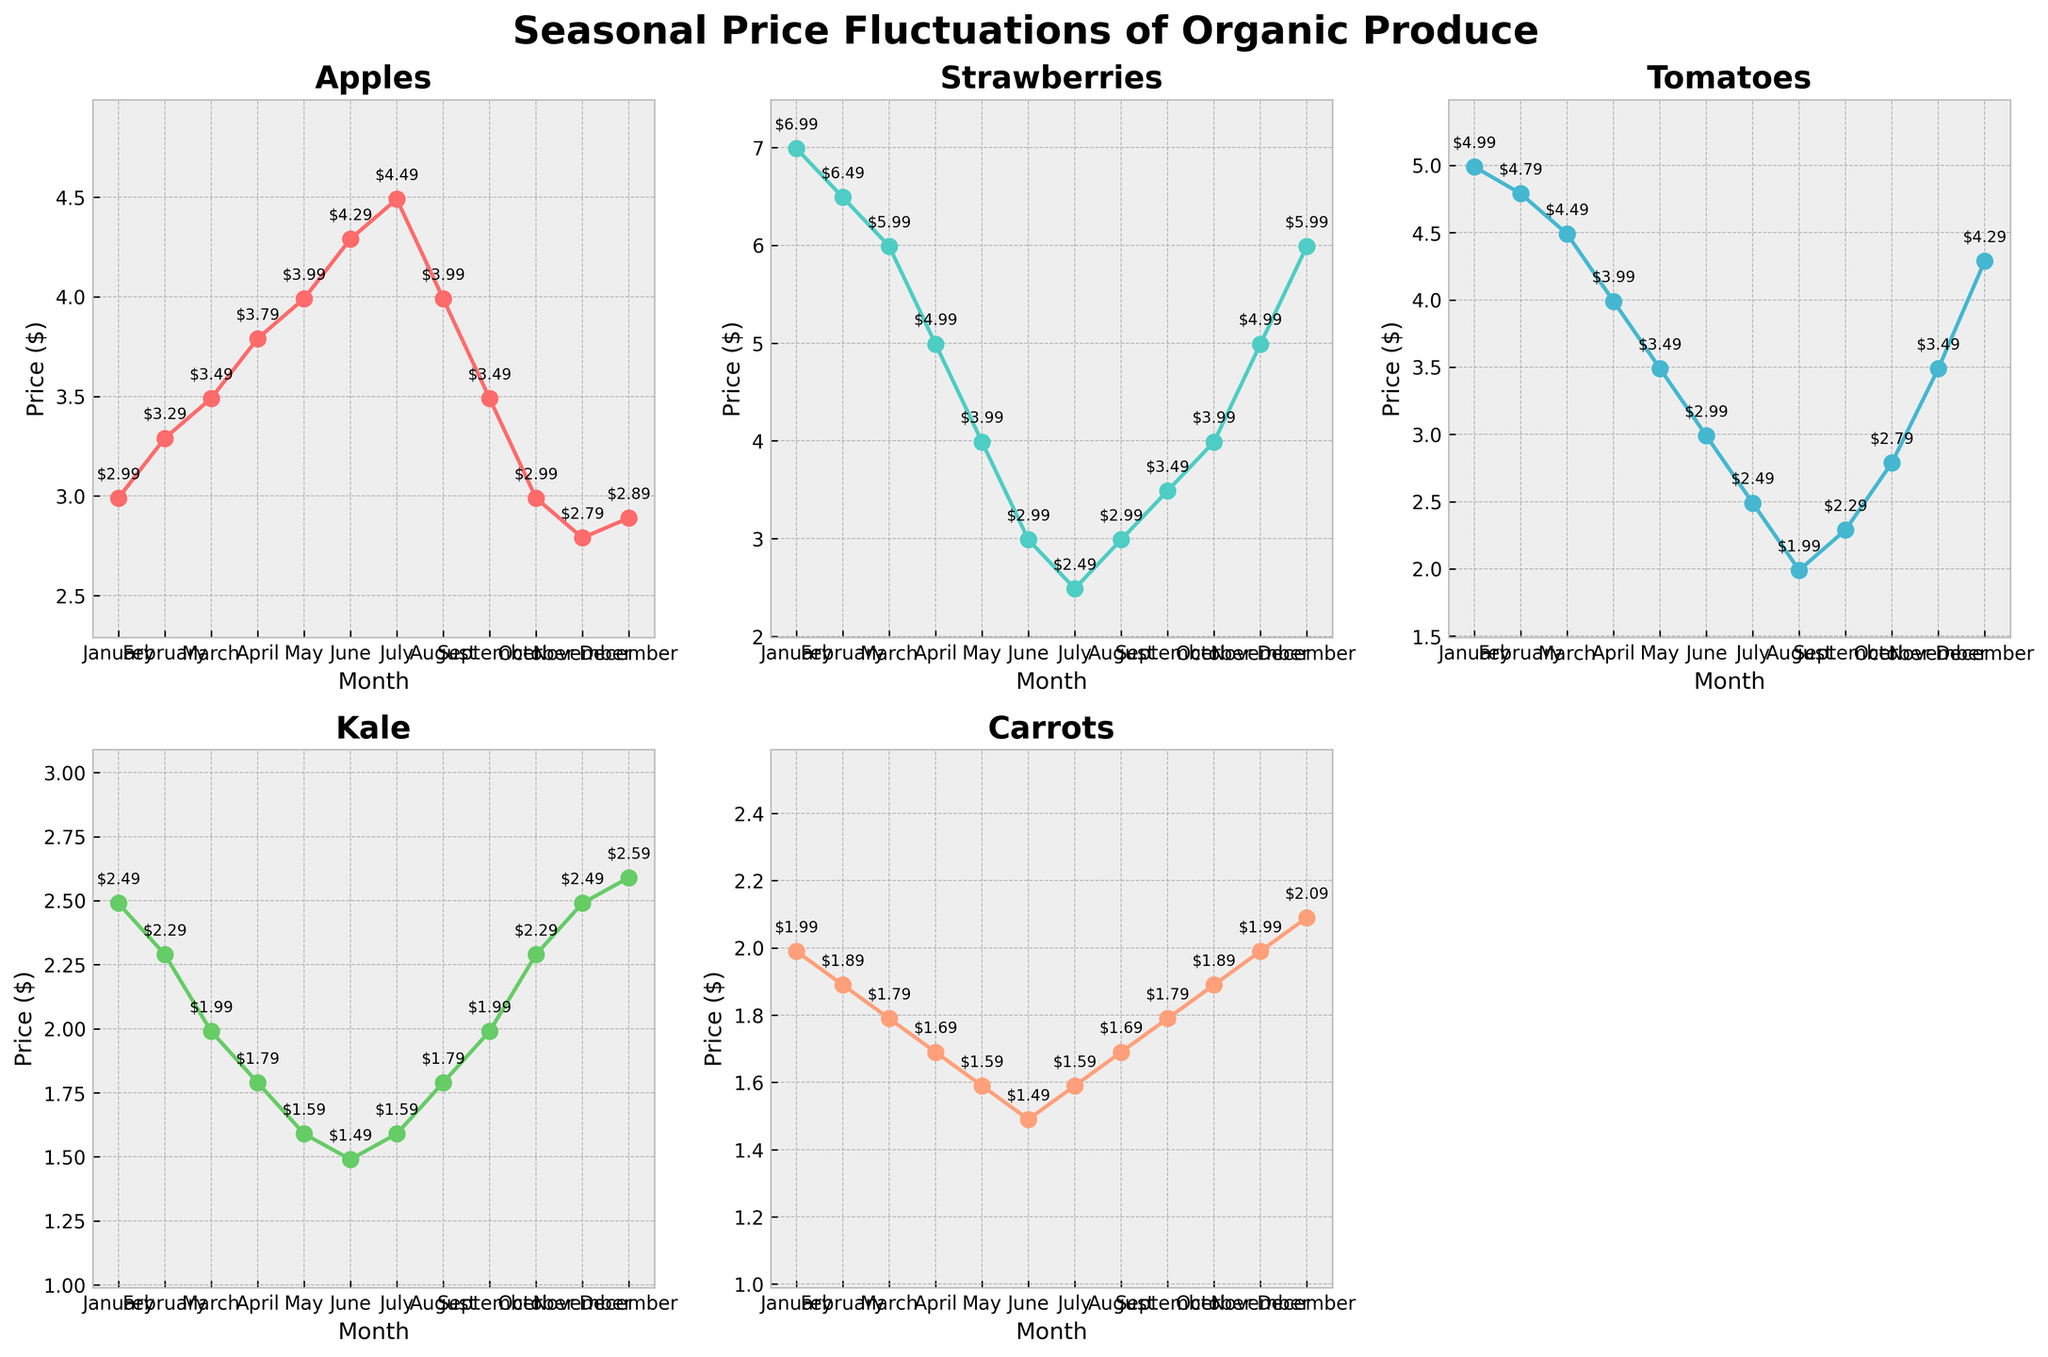What is the highest price for Strawberries throughout the year? Look at the subplot for Strawberries and identify the maximum y-value. The highest price for Strawberries is $6.99 in January.
Answer: $6.99 Which month has the lowest price for Tomatoes? Look at the subplot for Tomatoes and identify the minimum y-value. The lowest price for Tomatoes is $1.99 in August.
Answer: August How do the prices of Kale change from January to December? Observe the subplot for Kale. Note the prices in January and December, which are $2.49 and $2.59, respectively. Kale's price decreases and then slightly increases by the end of the year.
Answer: The price slightly increases What is the combined average price of Carrots in January, February, and March? Find the prices of Carrots in January, February, and March, which are $1.99, $1.89, and $1.79, respectively. Sum these prices (1.99 + 1.89 + 1.79 = 5.67) and divide by 3 to get the average (5.67/3 = 1.89).
Answer: $1.89 Which produce experiences the largest fluctuation in price throughout the year? Compare the price ranges for each produce by subtracting the minimum price from the maximum price. Strawberries have the largest fluctuation with a range from $6.99 to $2.49, which is a $4.50 difference.
Answer: Strawberries Is there any month where the prices of all five produces are at their lowest? Examine all subplots to find any common month where each produce has its minimum price. There is no single month where all produces are at their lowest prices.
Answer: No Between Apples and Carrots, which one shows a steady decline in price from June to November? Observe the subplots for Apples and Carrots. Apples have price fluctuations from June to November. Carrots show a steady decline from $1.49 in June to $1.99 in November.
Answer: Carrots How much more expensive are Tomatoes in April compared to August? Look at the subplot for Tomatoes and note their prices in April ($3.99) and August ($1.99). Subtract the August price from the April price to find the difference (3.99 - 1.99 = 2.00).
Answer: $2.00 Which produce has the most consistent price throughout the year? Examine the fluctuations in each subplot to identify the produce with the least change. Kale shows the least variation, with prices ranging from $1.49 to $2.59.
Answer: Kale 